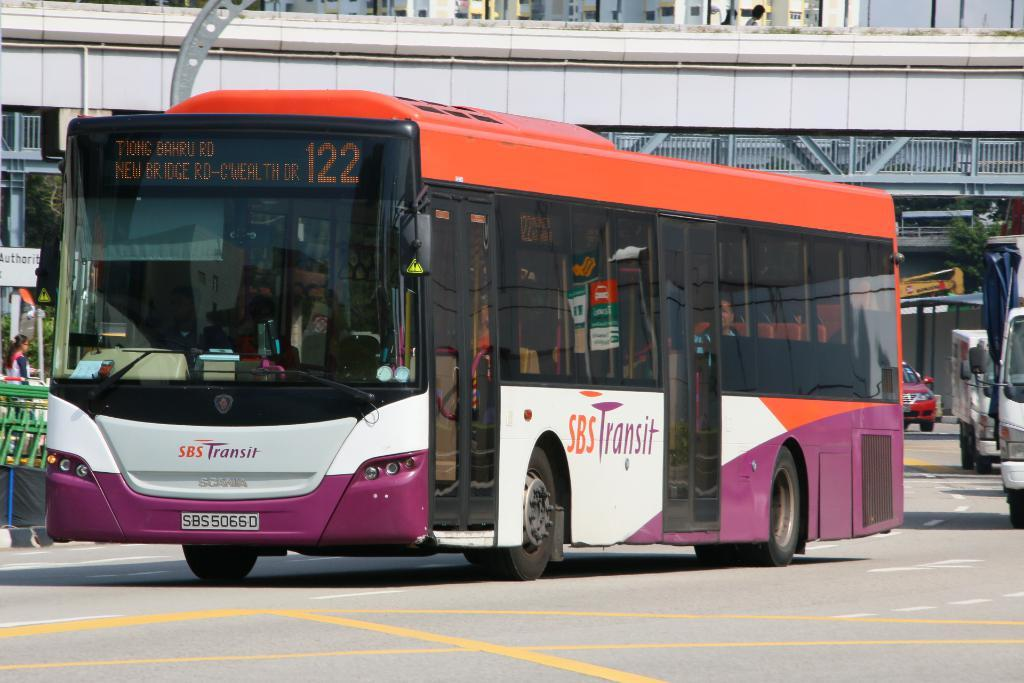<image>
Give a short and clear explanation of the subsequent image. An SBS Transit bus is painted orange and purple. 